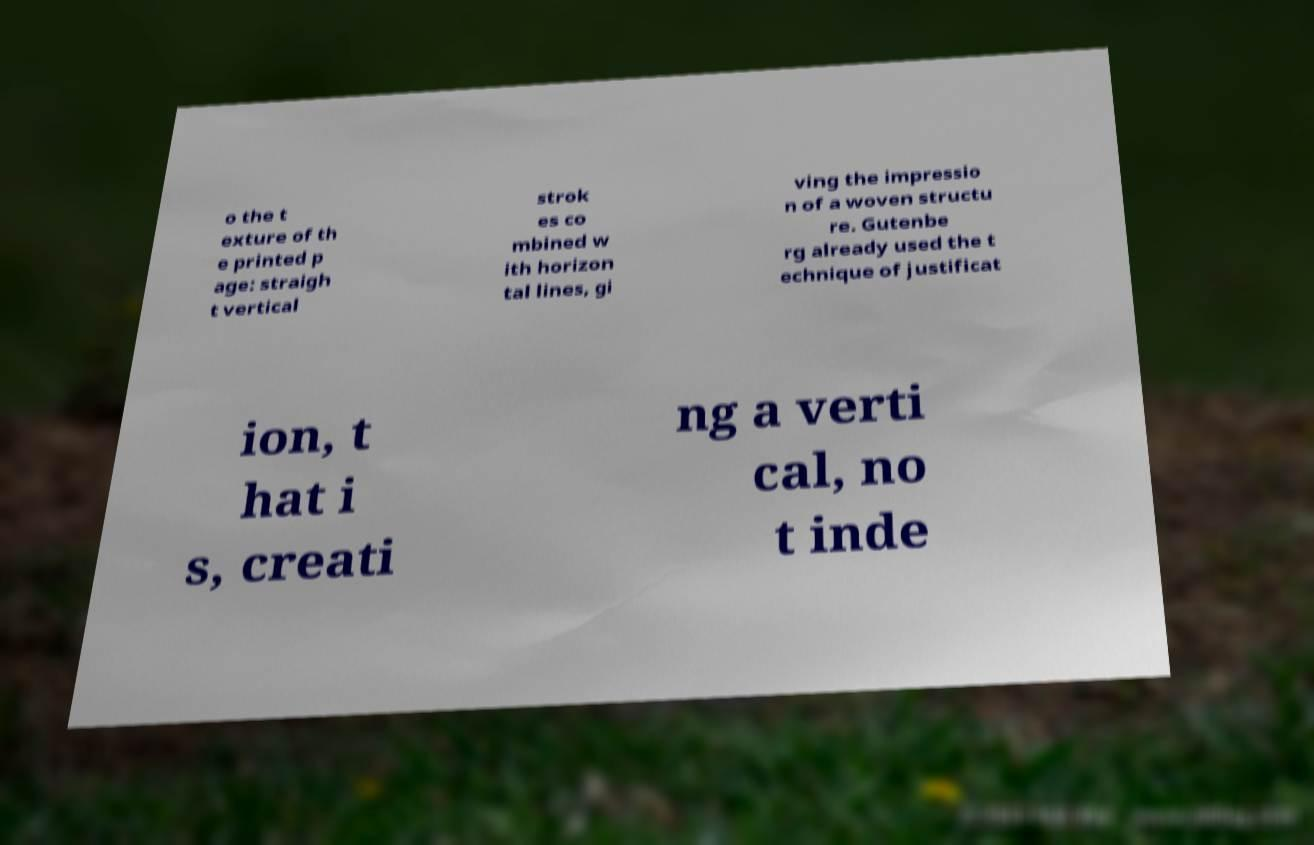Please identify and transcribe the text found in this image. o the t exture of th e printed p age: straigh t vertical strok es co mbined w ith horizon tal lines, gi ving the impressio n of a woven structu re. Gutenbe rg already used the t echnique of justificat ion, t hat i s, creati ng a verti cal, no t inde 